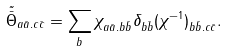Convert formula to latex. <formula><loc_0><loc_0><loc_500><loc_500>\tilde { \bar { \Theta } } _ { a \bar { a } . c \bar { c } } = \sum _ { b } \chi _ { a \bar { a } . b \bar { b } } \delta _ { b \bar { b } } ( \chi ^ { - 1 } ) _ { b \bar { b } . c \bar { c } } .</formula> 